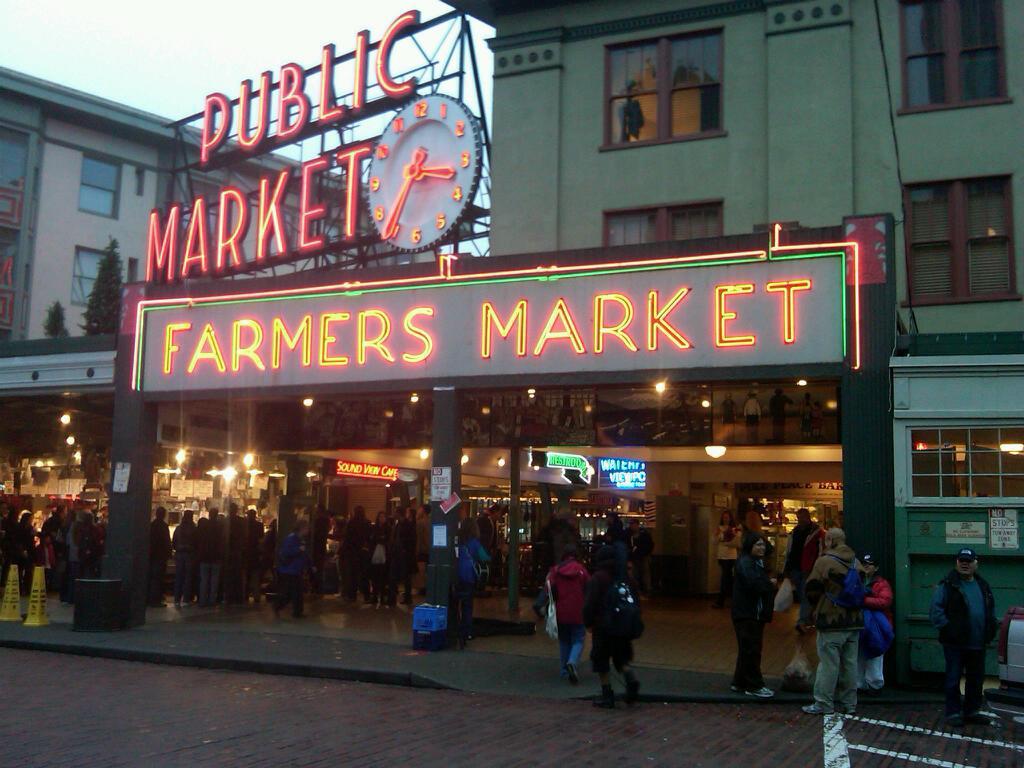Can you describe this image briefly? People are present. There are buildings. There is a led board on the top. There is an led hoarding and a clock beside it. There are trees at the left back. There is sky on the top. 